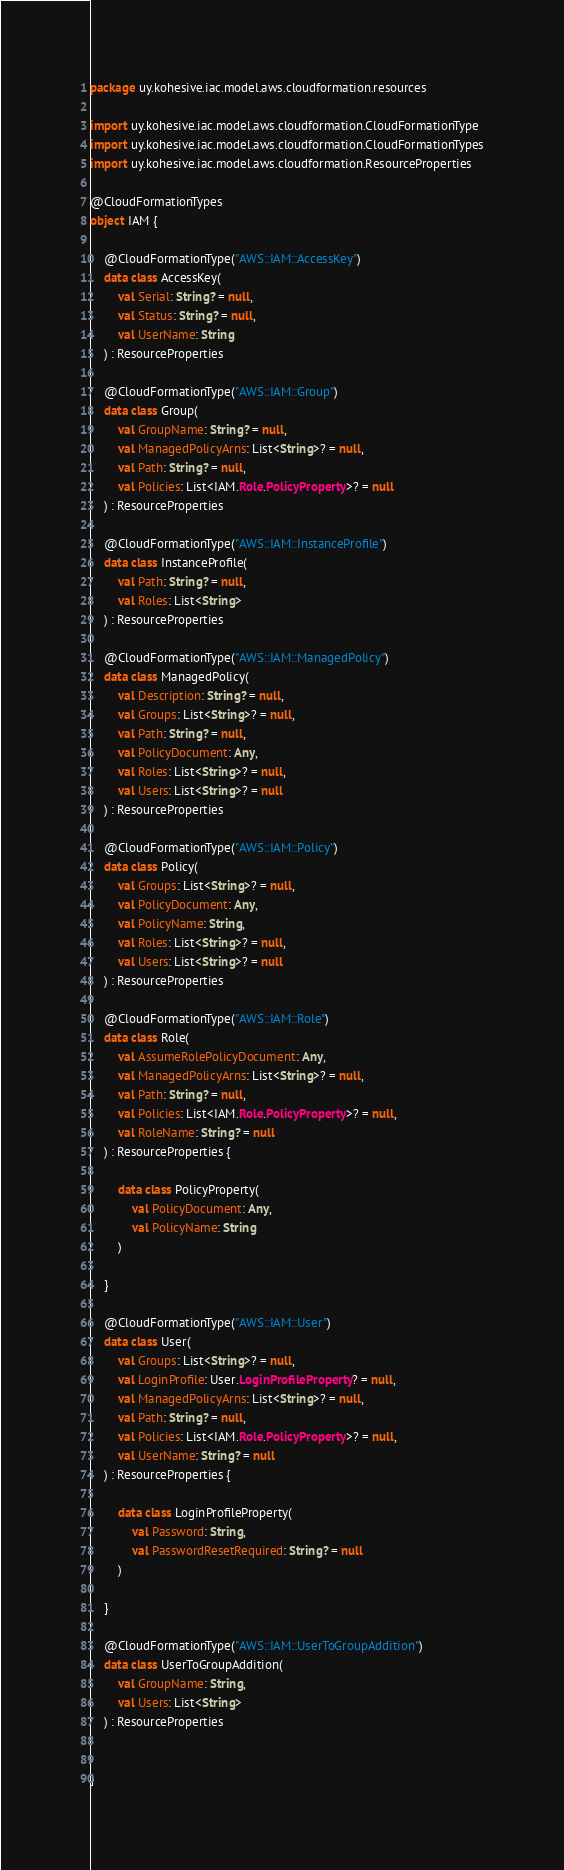Convert code to text. <code><loc_0><loc_0><loc_500><loc_500><_Kotlin_>package uy.kohesive.iac.model.aws.cloudformation.resources

import uy.kohesive.iac.model.aws.cloudformation.CloudFormationType
import uy.kohesive.iac.model.aws.cloudformation.CloudFormationTypes
import uy.kohesive.iac.model.aws.cloudformation.ResourceProperties

@CloudFormationTypes
object IAM {

    @CloudFormationType("AWS::IAM::AccessKey")
    data class AccessKey(
        val Serial: String? = null,
        val Status: String? = null,
        val UserName: String
    ) : ResourceProperties 

    @CloudFormationType("AWS::IAM::Group")
    data class Group(
        val GroupName: String? = null,
        val ManagedPolicyArns: List<String>? = null,
        val Path: String? = null,
        val Policies: List<IAM.Role.PolicyProperty>? = null
    ) : ResourceProperties 

    @CloudFormationType("AWS::IAM::InstanceProfile")
    data class InstanceProfile(
        val Path: String? = null,
        val Roles: List<String>
    ) : ResourceProperties 

    @CloudFormationType("AWS::IAM::ManagedPolicy")
    data class ManagedPolicy(
        val Description: String? = null,
        val Groups: List<String>? = null,
        val Path: String? = null,
        val PolicyDocument: Any,
        val Roles: List<String>? = null,
        val Users: List<String>? = null
    ) : ResourceProperties 

    @CloudFormationType("AWS::IAM::Policy")
    data class Policy(
        val Groups: List<String>? = null,
        val PolicyDocument: Any,
        val PolicyName: String,
        val Roles: List<String>? = null,
        val Users: List<String>? = null
    ) : ResourceProperties 

    @CloudFormationType("AWS::IAM::Role")
    data class Role(
        val AssumeRolePolicyDocument: Any,
        val ManagedPolicyArns: List<String>? = null,
        val Path: String? = null,
        val Policies: List<IAM.Role.PolicyProperty>? = null,
        val RoleName: String? = null
    ) : ResourceProperties {

        data class PolicyProperty(
            val PolicyDocument: Any,
            val PolicyName: String
        ) 

    }

    @CloudFormationType("AWS::IAM::User")
    data class User(
        val Groups: List<String>? = null,
        val LoginProfile: User.LoginProfileProperty? = null,
        val ManagedPolicyArns: List<String>? = null,
        val Path: String? = null,
        val Policies: List<IAM.Role.PolicyProperty>? = null,
        val UserName: String? = null
    ) : ResourceProperties {

        data class LoginProfileProperty(
            val Password: String,
            val PasswordResetRequired: String? = null
        ) 

    }

    @CloudFormationType("AWS::IAM::UserToGroupAddition")
    data class UserToGroupAddition(
        val GroupName: String,
        val Users: List<String>
    ) : ResourceProperties 


}</code> 